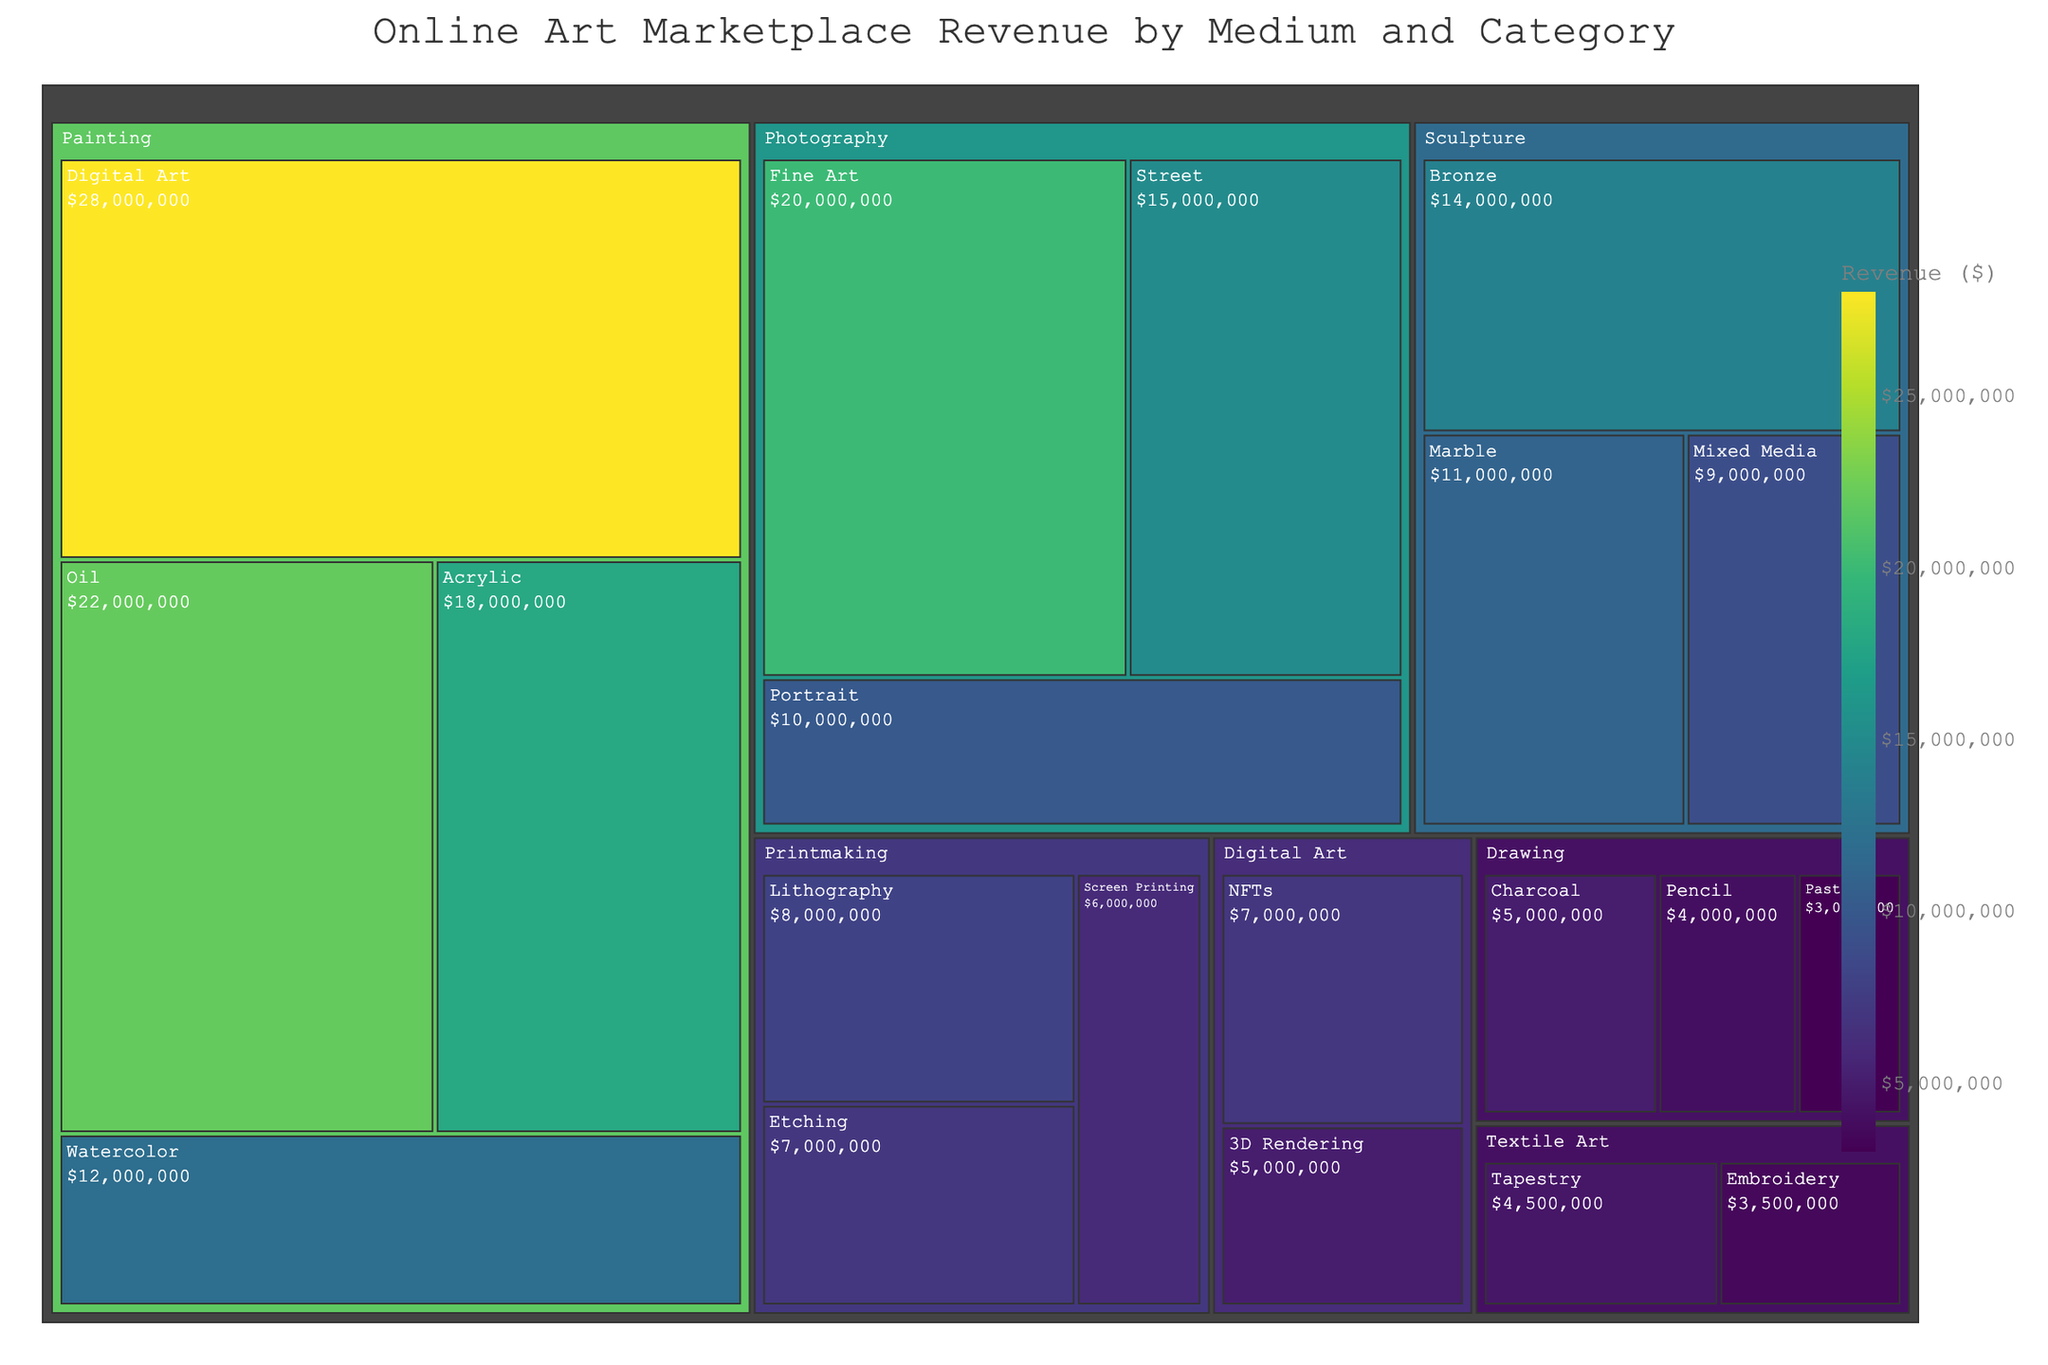what is the total revenue of the Painting medium? The total revenue of the Painting medium can be found by summing the revenues of all its categories: Digital Art ($28,000,000), Oil ($22,000,000), Acrylic ($18,000,000), and Watercolor ($12,000,000). The sum is $28,000,000 + $22,000,000 + $18,000,000 + $12,000,000.
Answer: $80,000,000 Which medium has the highest revenue among Photography, Sculpture, and Drawing? To determine which medium has the highest revenue, we sum up the revenues for each. Photography: Fine Art ($20,000,000), Street ($15,000,000), and Portrait ($10,000,000) totaling $45,000,000. Sculpture: Bronze ($14,000,000), Marble ($11,000,000), and Mixed Media ($9,000,000) totaling $34,000,000. Drawing: Charcoal ($5,000,000), Pencil ($4,000,000), and Pastel ($3,000,000) totaling $12,000,000. Comparing the totals, Photography has the highest revenue.
Answer: Photography What's the category with the least revenue in the Digital Art medium? Within the Digital Art medium, the categories are NFTs ($7,000,000) and 3D Rendering ($5,000,000). Comparing these values, 3D Rendering has the least revenue.
Answer: 3D Rendering Compare the combined revenue of Oil and Acrylic Paintings to the total revenue of all Drawing categories. Which is higher? First, sum the revenues of Oil and Acrylic Paintings: $22,000,000 (Oil) + $18,000,000 (Acrylic) = $40,000,000. Then, sum the revenues of all Drawing categories: Charcoal ($5,000,000), Pencil ($4,000,000), and Pastel ($3,000,000) totaling $12,000,000. Compare $40,000,000 to $12,000,000; the Oil and Acrylic Paintings have higher revenue.
Answer: Oil and Acrylic Paintings What is the total revenue generated by Printmaking and Textile Art combined? Add the total revenue for Printmaking categories: Lithography ($8,000,000), Etching ($7,000,000), and Screen Printing ($6,000,000) totaling $21,000,000. Then, add the revenue for Textile Art categories: Tapestry ($4,500,000) and Embroidery ($3,500,000) totaling $8,000,000. Finally, sum these totals: $21,000,000 + $8,000,000.
Answer: $29,000,000 Which category within the Sculpture medium generates more revenue: Bronze, or Marble and Mixed Media combined? First, find the revenue for Marble and Mixed Media combined: $11,000,000 (Marble) + $9,000,000 (Mixed Media) = $20,000,000. Then, compare this with the revenue of Bronze, which is $14,000,000. $20,000,000 (Marble and Mixed Media combined) is greater than $14,000,000 (Bronze).
Answer: Marble and Mixed Media combined By how much does the total revenue of the Painting medium exceed that of the Textile Art medium? The total revenue of Painting medium is $80,000,000, and the total revenue of Textile Art medium is $8,000,000. The difference between these two values is $80,000,000 - $8,000,000.
Answer: $72,000,000 Identify the medium with the highest single category revenue and name the category. The Digital Art medium's Digital Art category has a revenue of $28,000,000. This is the highest single category revenue compared to all other categories across mediums.
Answer: Digital Art What is the average revenue per category in the Drawing medium? The Drawing medium has the following revenues: Charcoal ($5,000,000), Pencil ($4,000,000), and Pastel ($3,000,000). Summing these gives $12,000,000. Dividing this total by the number of categories (3) yields $12,000,000/3.
Answer: $4,000,000 